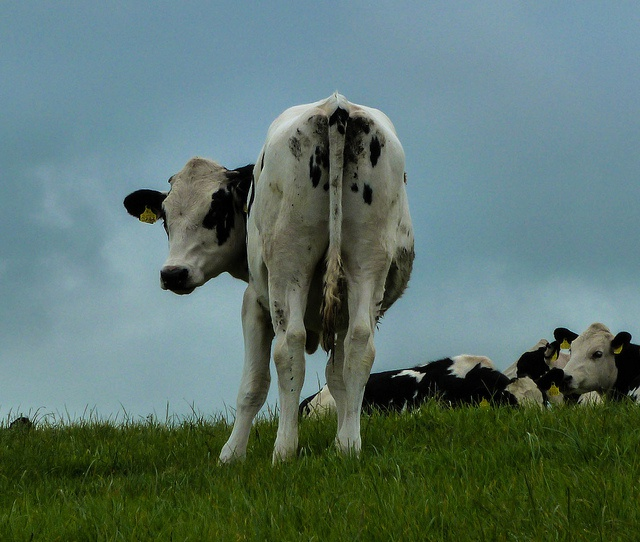Describe the objects in this image and their specific colors. I can see cow in gray, black, darkgray, and darkgreen tones, cow in gray, black, and darkgray tones, and cow in gray, black, and darkgreen tones in this image. 